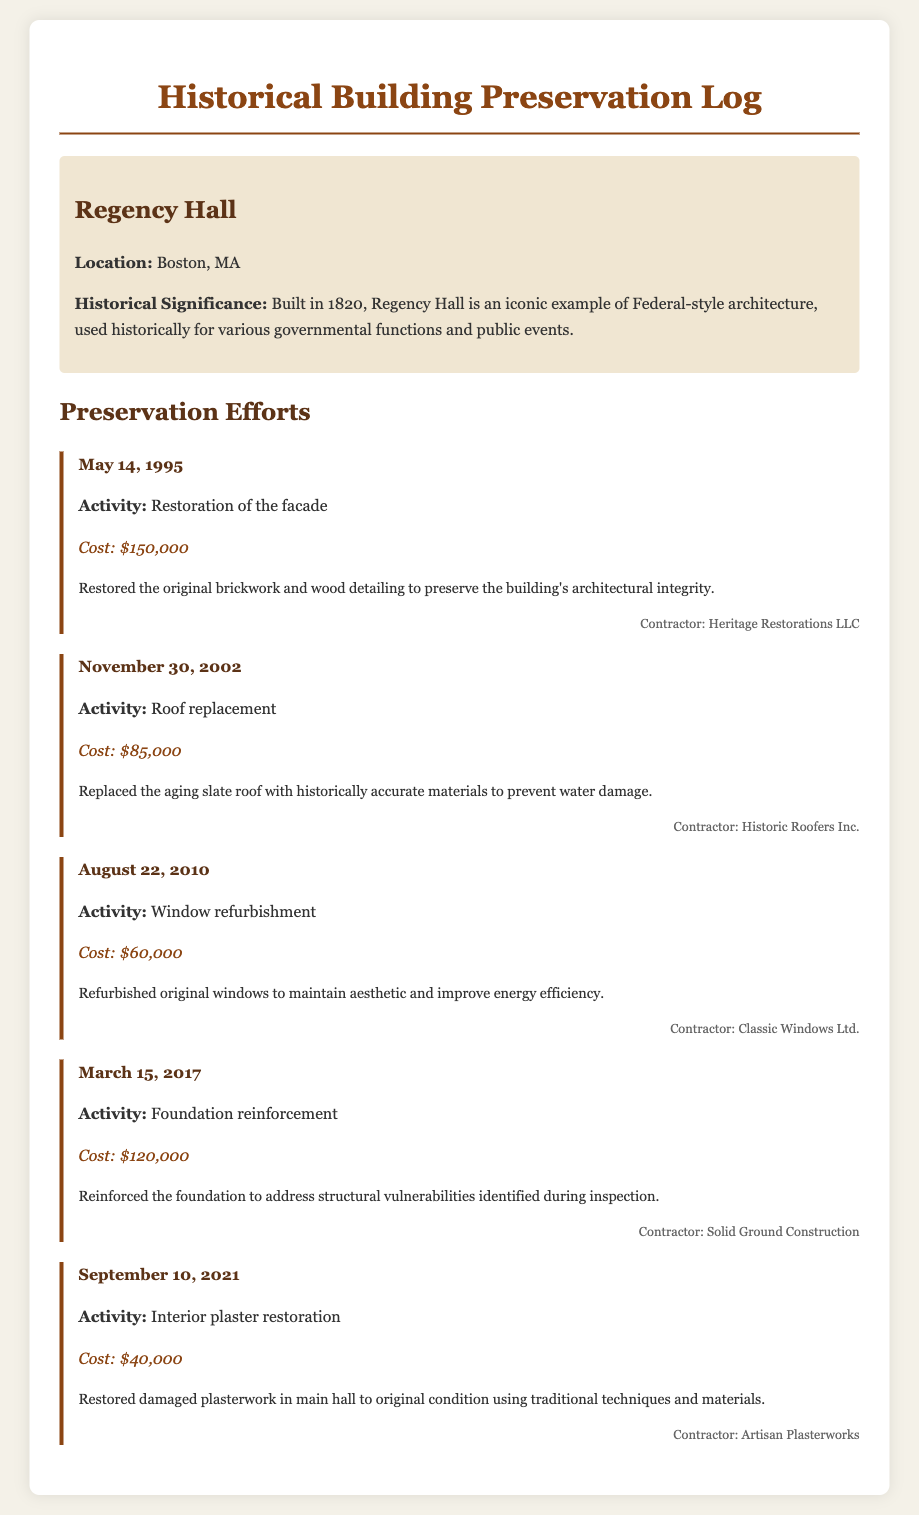What year was the facade restoration activity conducted? The restoration of the facade occurred on May 14, 1995.
Answer: 1995 Who was the contractor for the roof replacement? The roof replacement was handled by Historic Roofers Inc.
Answer: Historic Roofers Inc What was the cost of the foundation reinforcement? The foundation reinforcement cost was $120,000.
Answer: $120,000 What activity was performed on August 22, 2010? The activity performed on this date was window refurbishment.
Answer: Window refurbishment What is the historical significance of Regency Hall? Regency Hall is noted as an iconic example of Federal-style architecture, used for governmental functions.
Answer: Iconic example of Federal-style architecture How many maintenance activities are logged in the document? The document lists a total of five maintenance activities for Regency Hall.
Answer: Five What material was used for the roof replacement? The replacement used historically accurate materials.
Answer: Historically accurate materials What was the focus of the interior plaster restoration in 2021? The focus was to restore damaged plasterwork in the main hall.
Answer: Damaged plasterwork in the main hall 